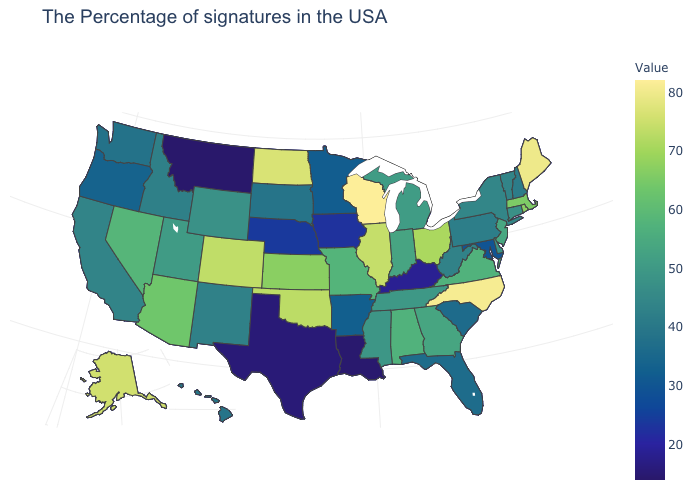Does Washington have a lower value than Delaware?
Keep it brief. Yes. Does the map have missing data?
Concise answer only. No. Which states have the lowest value in the USA?
Quick response, please. Montana. Which states have the lowest value in the South?
Keep it brief. Louisiana. Which states hav the highest value in the Northeast?
Quick response, please. Maine. 